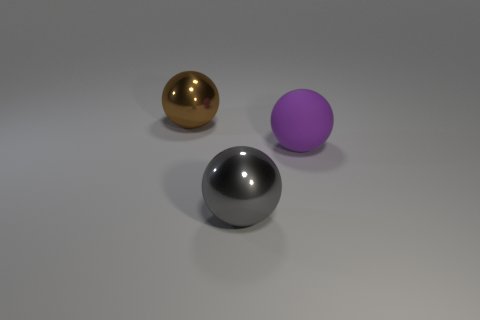Add 1 small gray metal blocks. How many objects exist? 4 Add 1 rubber spheres. How many rubber spheres exist? 2 Subtract 0 red cubes. How many objects are left? 3 Subtract all large purple objects. Subtract all big metal balls. How many objects are left? 0 Add 1 large gray objects. How many large gray objects are left? 2 